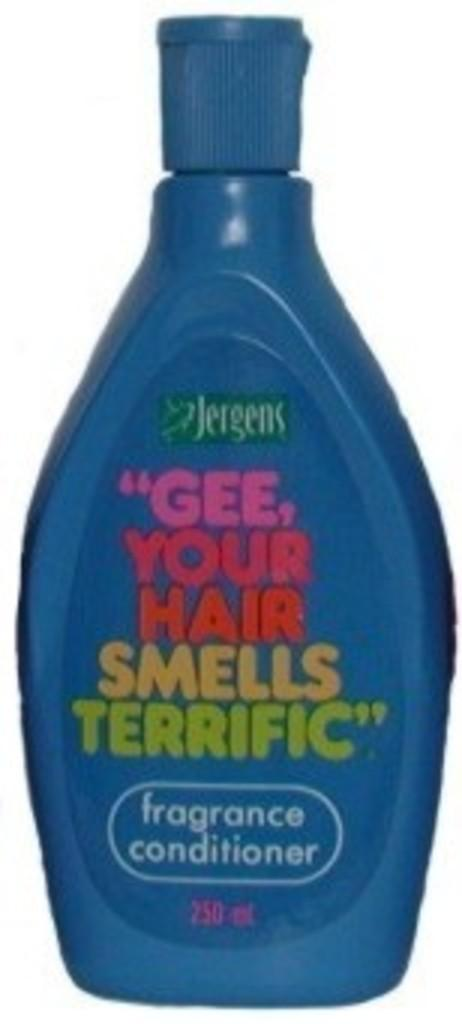<image>
Create a compact narrative representing the image presented. A blue 250 ml bottle of Jergens conditioner. 